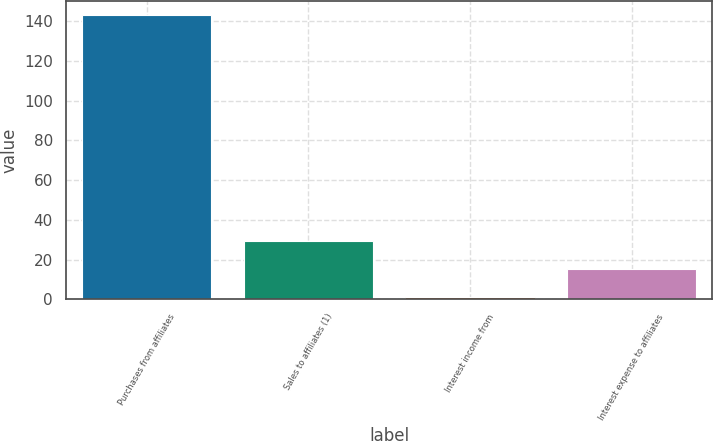<chart> <loc_0><loc_0><loc_500><loc_500><bar_chart><fcel>Purchases from affiliates<fcel>Sales to affiliates (1)<fcel>Interest income from<fcel>Interest expense to affiliates<nl><fcel>143<fcel>29.4<fcel>1<fcel>15.2<nl></chart> 